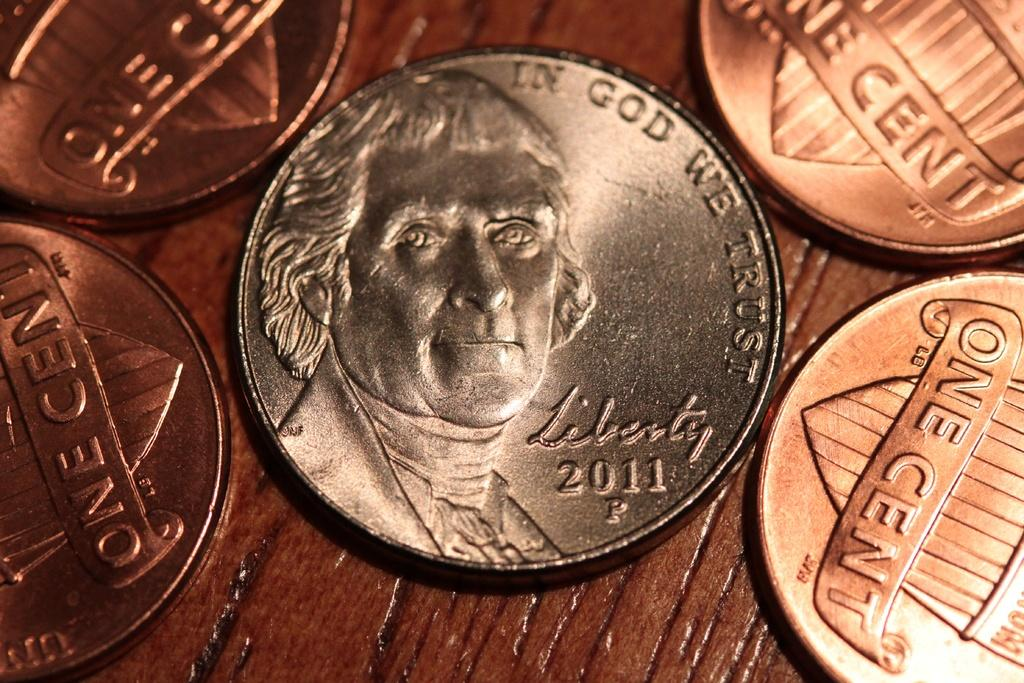<image>
Render a clear and concise summary of the photo. A 2011 shiny silver coin is sitting with some pennies. 